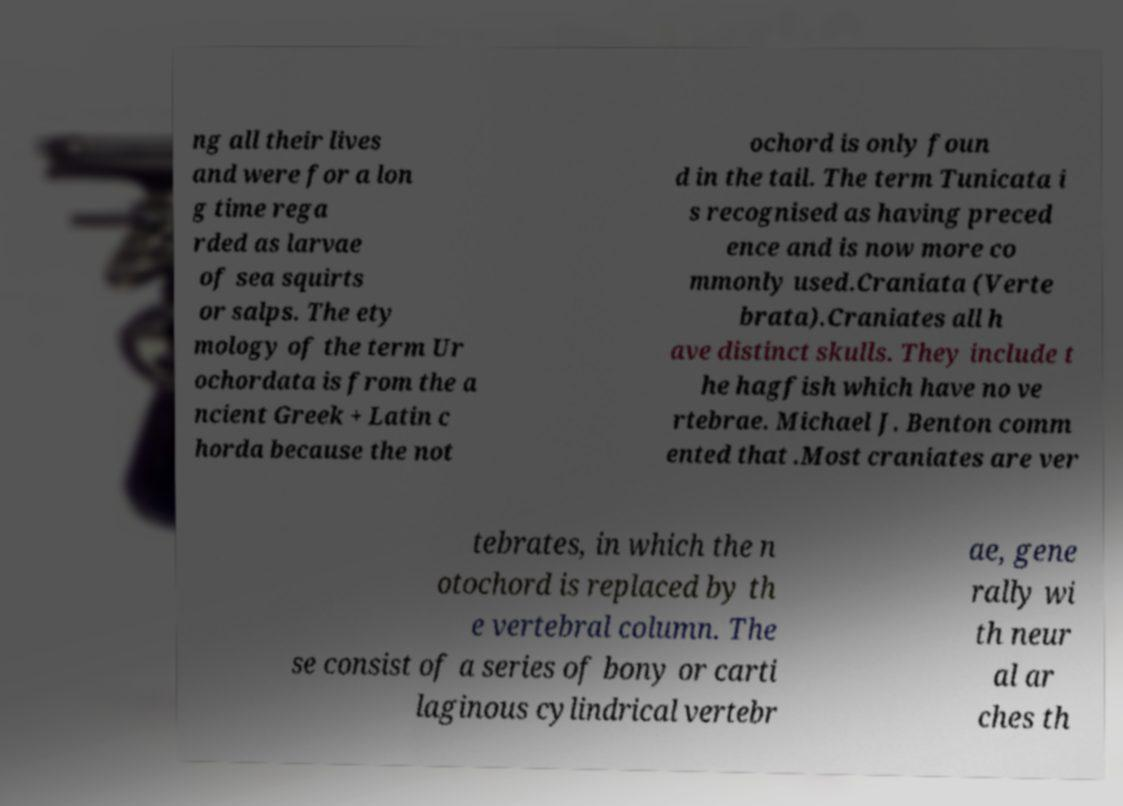Can you accurately transcribe the text from the provided image for me? ng all their lives and were for a lon g time rega rded as larvae of sea squirts or salps. The ety mology of the term Ur ochordata is from the a ncient Greek + Latin c horda because the not ochord is only foun d in the tail. The term Tunicata i s recognised as having preced ence and is now more co mmonly used.Craniata (Verte brata).Craniates all h ave distinct skulls. They include t he hagfish which have no ve rtebrae. Michael J. Benton comm ented that .Most craniates are ver tebrates, in which the n otochord is replaced by th e vertebral column. The se consist of a series of bony or carti laginous cylindrical vertebr ae, gene rally wi th neur al ar ches th 